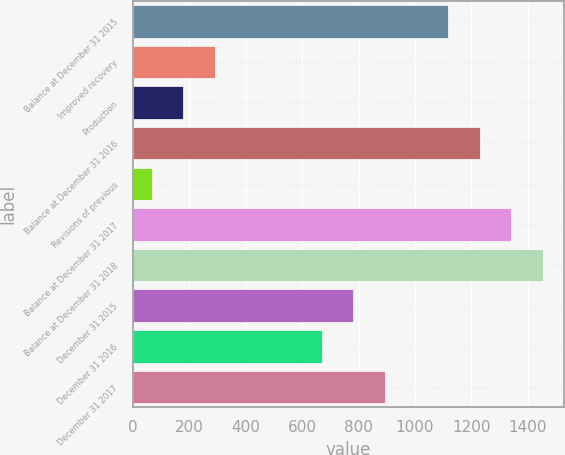Convert chart to OTSL. <chart><loc_0><loc_0><loc_500><loc_500><bar_chart><fcel>Balance at December 31 2015<fcel>Improved recovery<fcel>Production<fcel>Balance at December 31 2016<fcel>Revisions of previous<fcel>Balance at December 31 2017<fcel>Balance at December 31 2018<fcel>December 31 2015<fcel>December 31 2016<fcel>December 31 2017<nl><fcel>1118<fcel>290<fcel>178<fcel>1230<fcel>66<fcel>1342<fcel>1454<fcel>782<fcel>670<fcel>894<nl></chart> 